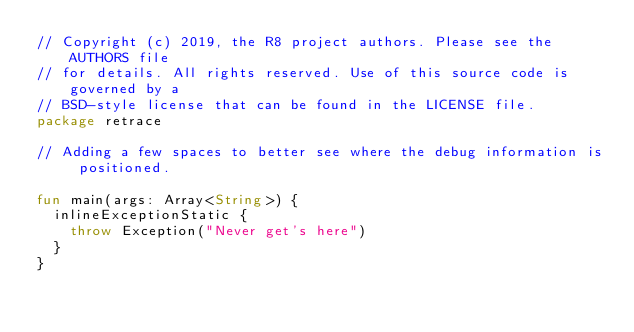Convert code to text. <code><loc_0><loc_0><loc_500><loc_500><_Kotlin_>// Copyright (c) 2019, the R8 project authors. Please see the AUTHORS file
// for details. All rights reserved. Use of this source code is governed by a
// BSD-style license that can be found in the LICENSE file.
package retrace

// Adding a few spaces to better see where the debug information is positioned.

fun main(args: Array<String>) {
  inlineExceptionStatic {
    throw Exception("Never get's here")
  }
}
</code> 